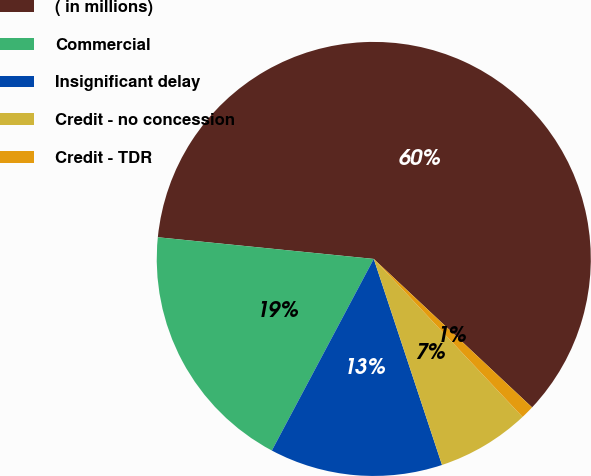Convert chart. <chart><loc_0><loc_0><loc_500><loc_500><pie_chart><fcel>( in millions)<fcel>Commercial<fcel>Insignificant delay<fcel>Credit - no concession<fcel>Credit - TDR<nl><fcel>60.39%<fcel>18.81%<fcel>12.87%<fcel>6.93%<fcel>0.99%<nl></chart> 